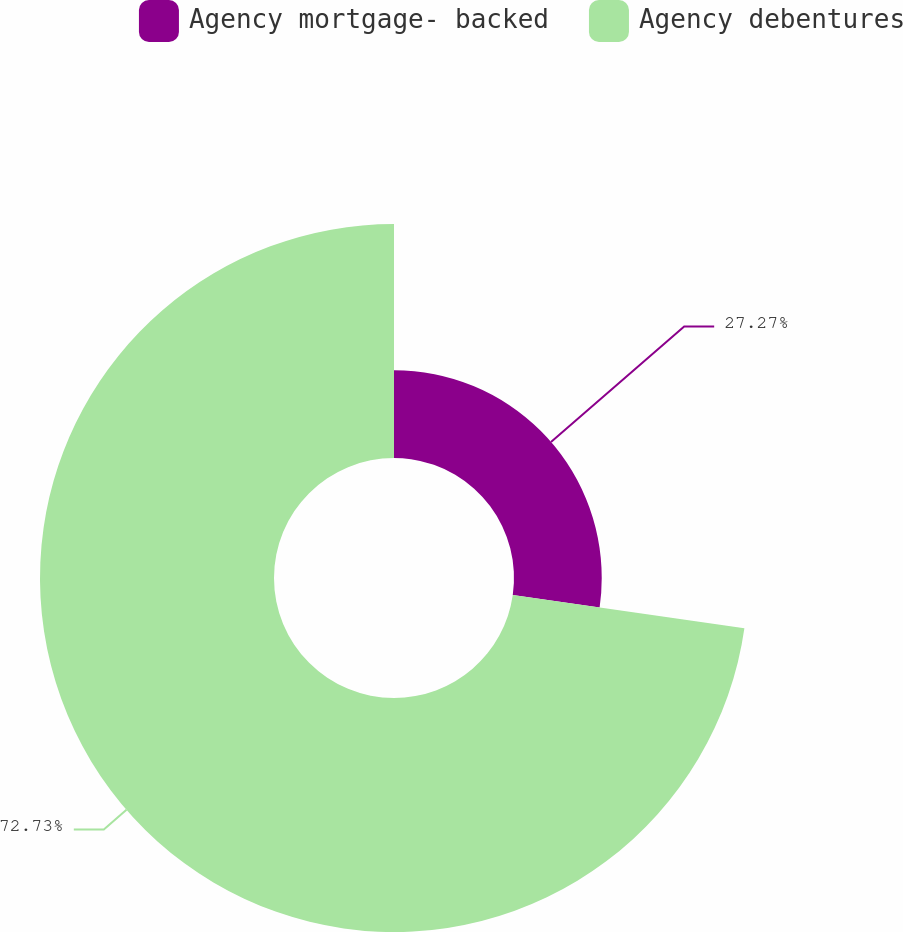<chart> <loc_0><loc_0><loc_500><loc_500><pie_chart><fcel>Agency mortgage- backed<fcel>Agency debentures<nl><fcel>27.27%<fcel>72.73%<nl></chart> 